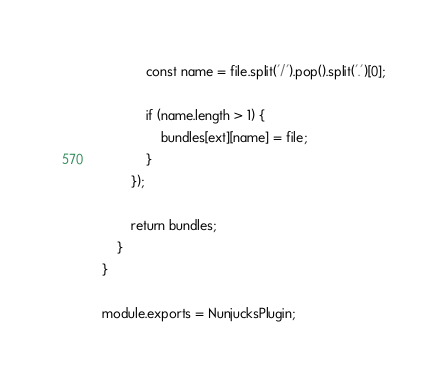Convert code to text. <code><loc_0><loc_0><loc_500><loc_500><_JavaScript_>            const name = file.split('/').pop().split('.')[0];

            if (name.length > 1) {
                bundles[ext][name] = file;
            }
        });

        return bundles;
    }
}

module.exports = NunjucksPlugin;</code> 